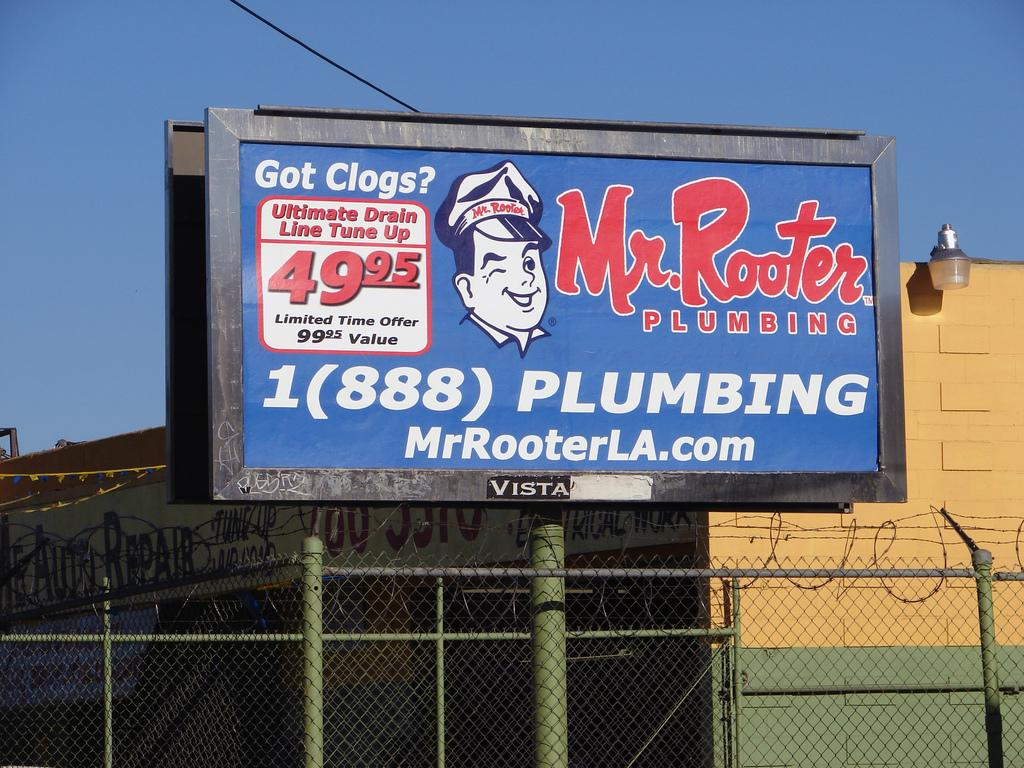<image>
Relay a brief, clear account of the picture shown. An outdoor billboard ad for Mr. Rooter plumbing. 